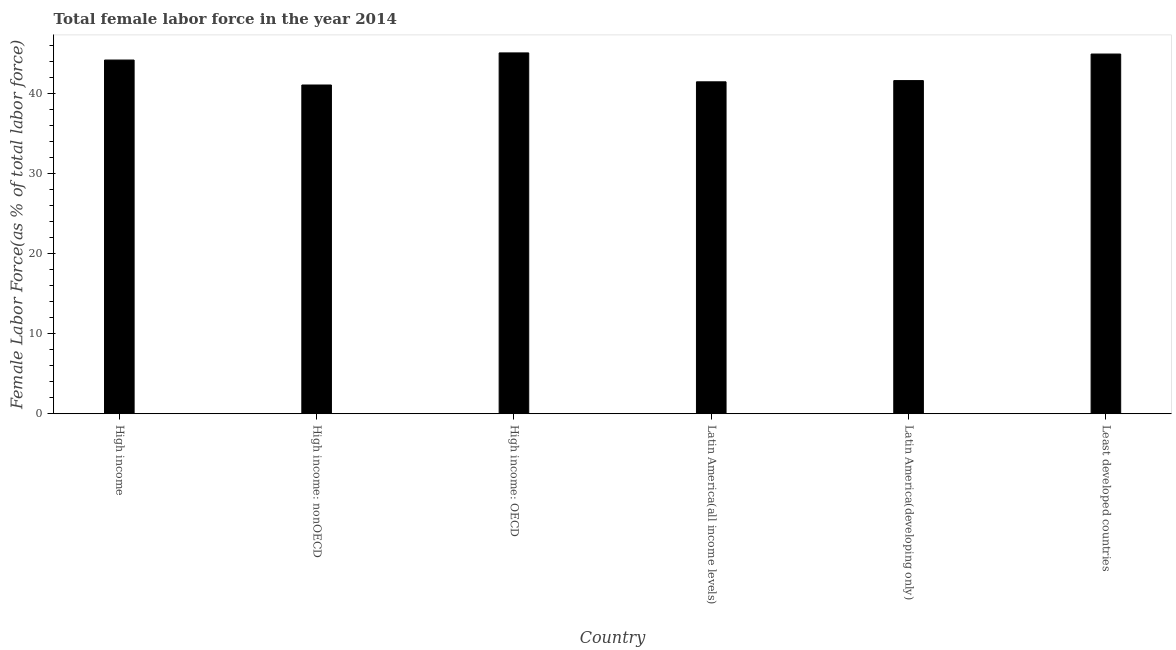What is the title of the graph?
Your answer should be very brief. Total female labor force in the year 2014. What is the label or title of the X-axis?
Your answer should be very brief. Country. What is the label or title of the Y-axis?
Your response must be concise. Female Labor Force(as % of total labor force). What is the total female labor force in Latin America(developing only)?
Offer a terse response. 41.64. Across all countries, what is the maximum total female labor force?
Provide a short and direct response. 45.1. Across all countries, what is the minimum total female labor force?
Offer a terse response. 41.09. In which country was the total female labor force maximum?
Your response must be concise. High income: OECD. In which country was the total female labor force minimum?
Provide a short and direct response. High income: nonOECD. What is the sum of the total female labor force?
Give a very brief answer. 258.48. What is the difference between the total female labor force in High income: OECD and High income: nonOECD?
Ensure brevity in your answer.  4.01. What is the average total female labor force per country?
Make the answer very short. 43.08. What is the median total female labor force?
Offer a terse response. 42.92. What is the ratio of the total female labor force in High income: nonOECD to that in Least developed countries?
Offer a terse response. 0.91. Is the total female labor force in High income: nonOECD less than that in Latin America(all income levels)?
Offer a terse response. Yes. Is the difference between the total female labor force in High income: OECD and High income: nonOECD greater than the difference between any two countries?
Your response must be concise. Yes. What is the difference between the highest and the second highest total female labor force?
Your response must be concise. 0.14. Is the sum of the total female labor force in Latin America(all income levels) and Latin America(developing only) greater than the maximum total female labor force across all countries?
Ensure brevity in your answer.  Yes. What is the difference between the highest and the lowest total female labor force?
Your answer should be very brief. 4.01. Are all the bars in the graph horizontal?
Your answer should be compact. No. What is the Female Labor Force(as % of total labor force) in High income?
Your answer should be very brief. 44.21. What is the Female Labor Force(as % of total labor force) in High income: nonOECD?
Provide a short and direct response. 41.09. What is the Female Labor Force(as % of total labor force) in High income: OECD?
Offer a terse response. 45.1. What is the Female Labor Force(as % of total labor force) in Latin America(all income levels)?
Offer a terse response. 41.49. What is the Female Labor Force(as % of total labor force) in Latin America(developing only)?
Offer a very short reply. 41.64. What is the Female Labor Force(as % of total labor force) of Least developed countries?
Your answer should be very brief. 44.96. What is the difference between the Female Labor Force(as % of total labor force) in High income and High income: nonOECD?
Ensure brevity in your answer.  3.12. What is the difference between the Female Labor Force(as % of total labor force) in High income and High income: OECD?
Keep it short and to the point. -0.89. What is the difference between the Female Labor Force(as % of total labor force) in High income and Latin America(all income levels)?
Make the answer very short. 2.72. What is the difference between the Female Labor Force(as % of total labor force) in High income and Latin America(developing only)?
Offer a very short reply. 2.57. What is the difference between the Female Labor Force(as % of total labor force) in High income and Least developed countries?
Offer a terse response. -0.75. What is the difference between the Female Labor Force(as % of total labor force) in High income: nonOECD and High income: OECD?
Give a very brief answer. -4.01. What is the difference between the Female Labor Force(as % of total labor force) in High income: nonOECD and Latin America(all income levels)?
Keep it short and to the point. -0.4. What is the difference between the Female Labor Force(as % of total labor force) in High income: nonOECD and Latin America(developing only)?
Your answer should be very brief. -0.55. What is the difference between the Female Labor Force(as % of total labor force) in High income: nonOECD and Least developed countries?
Ensure brevity in your answer.  -3.87. What is the difference between the Female Labor Force(as % of total labor force) in High income: OECD and Latin America(all income levels)?
Ensure brevity in your answer.  3.61. What is the difference between the Female Labor Force(as % of total labor force) in High income: OECD and Latin America(developing only)?
Offer a terse response. 3.46. What is the difference between the Female Labor Force(as % of total labor force) in High income: OECD and Least developed countries?
Make the answer very short. 0.14. What is the difference between the Female Labor Force(as % of total labor force) in Latin America(all income levels) and Latin America(developing only)?
Offer a very short reply. -0.15. What is the difference between the Female Labor Force(as % of total labor force) in Latin America(all income levels) and Least developed countries?
Provide a short and direct response. -3.47. What is the difference between the Female Labor Force(as % of total labor force) in Latin America(developing only) and Least developed countries?
Make the answer very short. -3.32. What is the ratio of the Female Labor Force(as % of total labor force) in High income to that in High income: nonOECD?
Give a very brief answer. 1.08. What is the ratio of the Female Labor Force(as % of total labor force) in High income to that in Latin America(all income levels)?
Ensure brevity in your answer.  1.07. What is the ratio of the Female Labor Force(as % of total labor force) in High income to that in Latin America(developing only)?
Ensure brevity in your answer.  1.06. What is the ratio of the Female Labor Force(as % of total labor force) in High income: nonOECD to that in High income: OECD?
Make the answer very short. 0.91. What is the ratio of the Female Labor Force(as % of total labor force) in High income: nonOECD to that in Latin America(all income levels)?
Give a very brief answer. 0.99. What is the ratio of the Female Labor Force(as % of total labor force) in High income: nonOECD to that in Least developed countries?
Offer a terse response. 0.91. What is the ratio of the Female Labor Force(as % of total labor force) in High income: OECD to that in Latin America(all income levels)?
Provide a succinct answer. 1.09. What is the ratio of the Female Labor Force(as % of total labor force) in High income: OECD to that in Latin America(developing only)?
Make the answer very short. 1.08. What is the ratio of the Female Labor Force(as % of total labor force) in High income: OECD to that in Least developed countries?
Provide a succinct answer. 1. What is the ratio of the Female Labor Force(as % of total labor force) in Latin America(all income levels) to that in Latin America(developing only)?
Your response must be concise. 1. What is the ratio of the Female Labor Force(as % of total labor force) in Latin America(all income levels) to that in Least developed countries?
Ensure brevity in your answer.  0.92. What is the ratio of the Female Labor Force(as % of total labor force) in Latin America(developing only) to that in Least developed countries?
Make the answer very short. 0.93. 